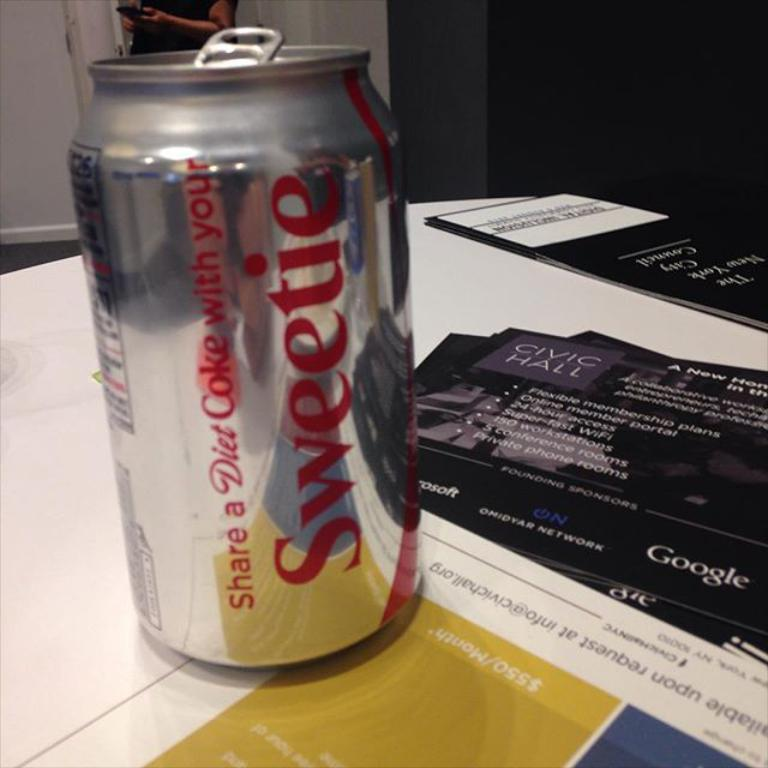Provide a one-sentence caption for the provided image. A can of Diet Coke says "sweetie" on the side. 